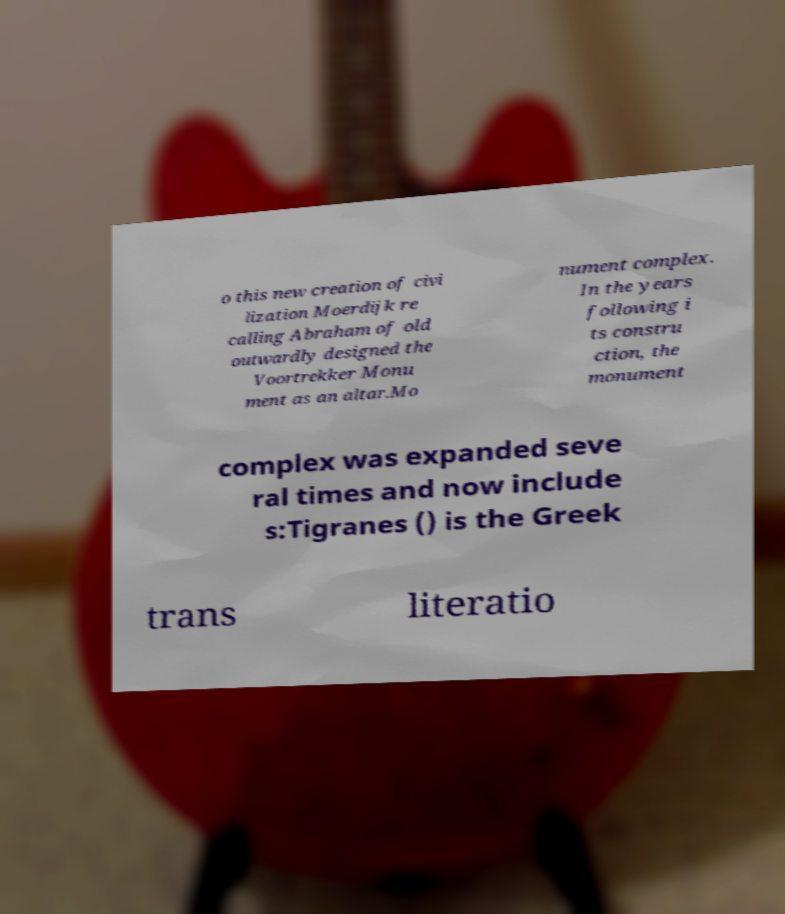I need the written content from this picture converted into text. Can you do that? o this new creation of civi lization Moerdijk re calling Abraham of old outwardly designed the Voortrekker Monu ment as an altar.Mo nument complex. In the years following i ts constru ction, the monument complex was expanded seve ral times and now include s:Tigranes () is the Greek trans literatio 